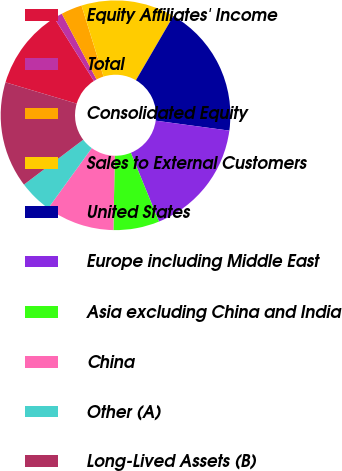Convert chart. <chart><loc_0><loc_0><loc_500><loc_500><pie_chart><fcel>Equity Affiliates' Income<fcel>Total<fcel>Consolidated Equity<fcel>Sales to External Customers<fcel>United States<fcel>Europe including Middle East<fcel>Asia excluding China and India<fcel>China<fcel>Other (A)<fcel>Long-Lived Assets (B)<nl><fcel>11.43%<fcel>1.2%<fcel>2.96%<fcel>13.18%<fcel>18.74%<fcel>16.69%<fcel>6.47%<fcel>9.68%<fcel>4.71%<fcel>14.94%<nl></chart> 